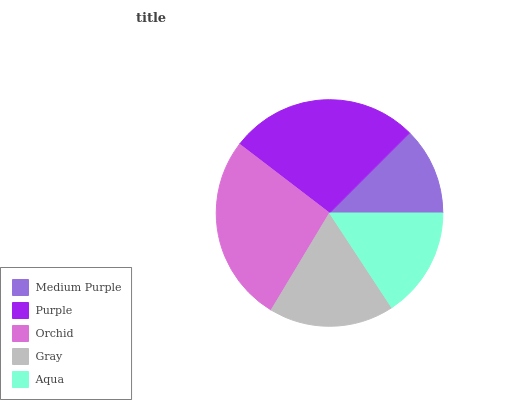Is Medium Purple the minimum?
Answer yes or no. Yes. Is Purple the maximum?
Answer yes or no. Yes. Is Orchid the minimum?
Answer yes or no. No. Is Orchid the maximum?
Answer yes or no. No. Is Purple greater than Orchid?
Answer yes or no. Yes. Is Orchid less than Purple?
Answer yes or no. Yes. Is Orchid greater than Purple?
Answer yes or no. No. Is Purple less than Orchid?
Answer yes or no. No. Is Gray the high median?
Answer yes or no. Yes. Is Gray the low median?
Answer yes or no. Yes. Is Purple the high median?
Answer yes or no. No. Is Aqua the low median?
Answer yes or no. No. 